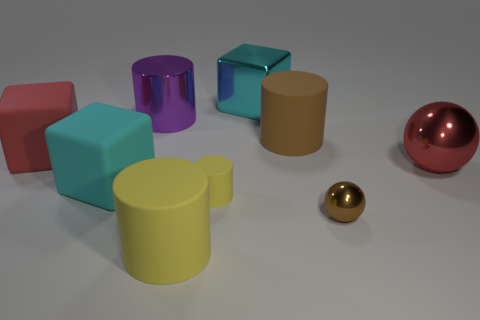How many other things are there of the same size as the purple cylinder? Upon reviewing the image, it appears there is one object that closely resembles the size of the purple cylinder, which is the yellow cylinder. So, there is one object of the same size as the purple cylinder. 